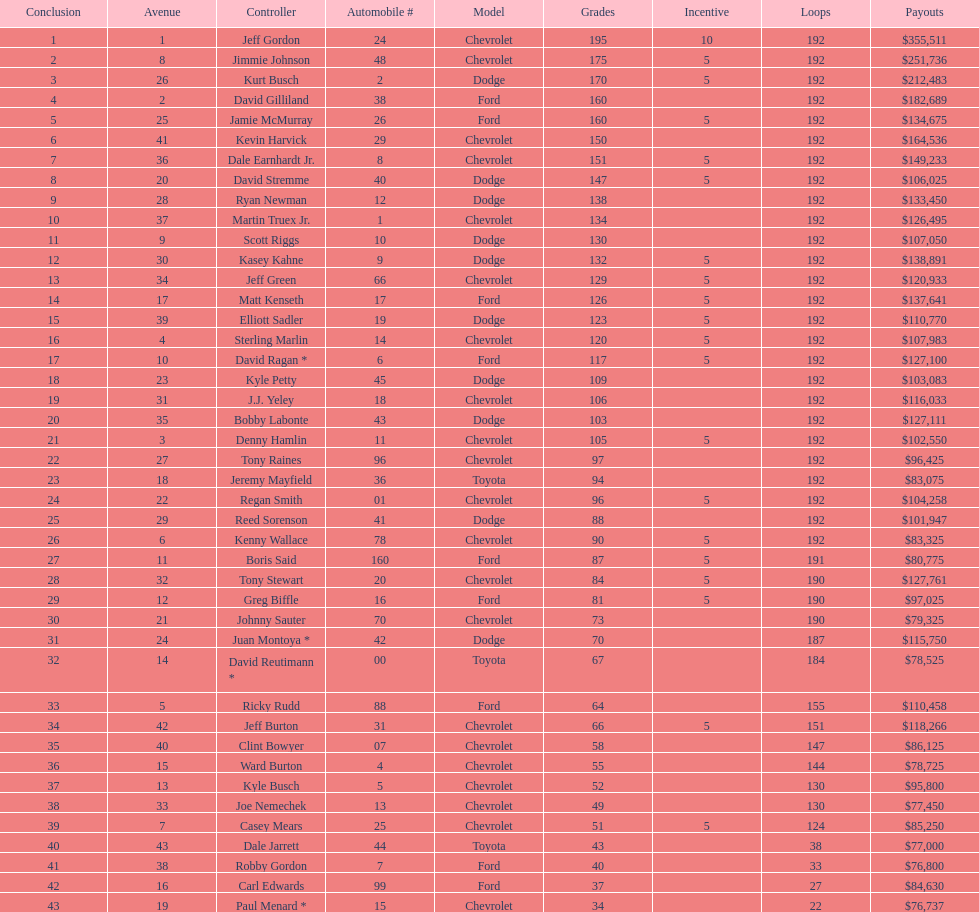What driver earned the least amount of winnings? Paul Menard *. 